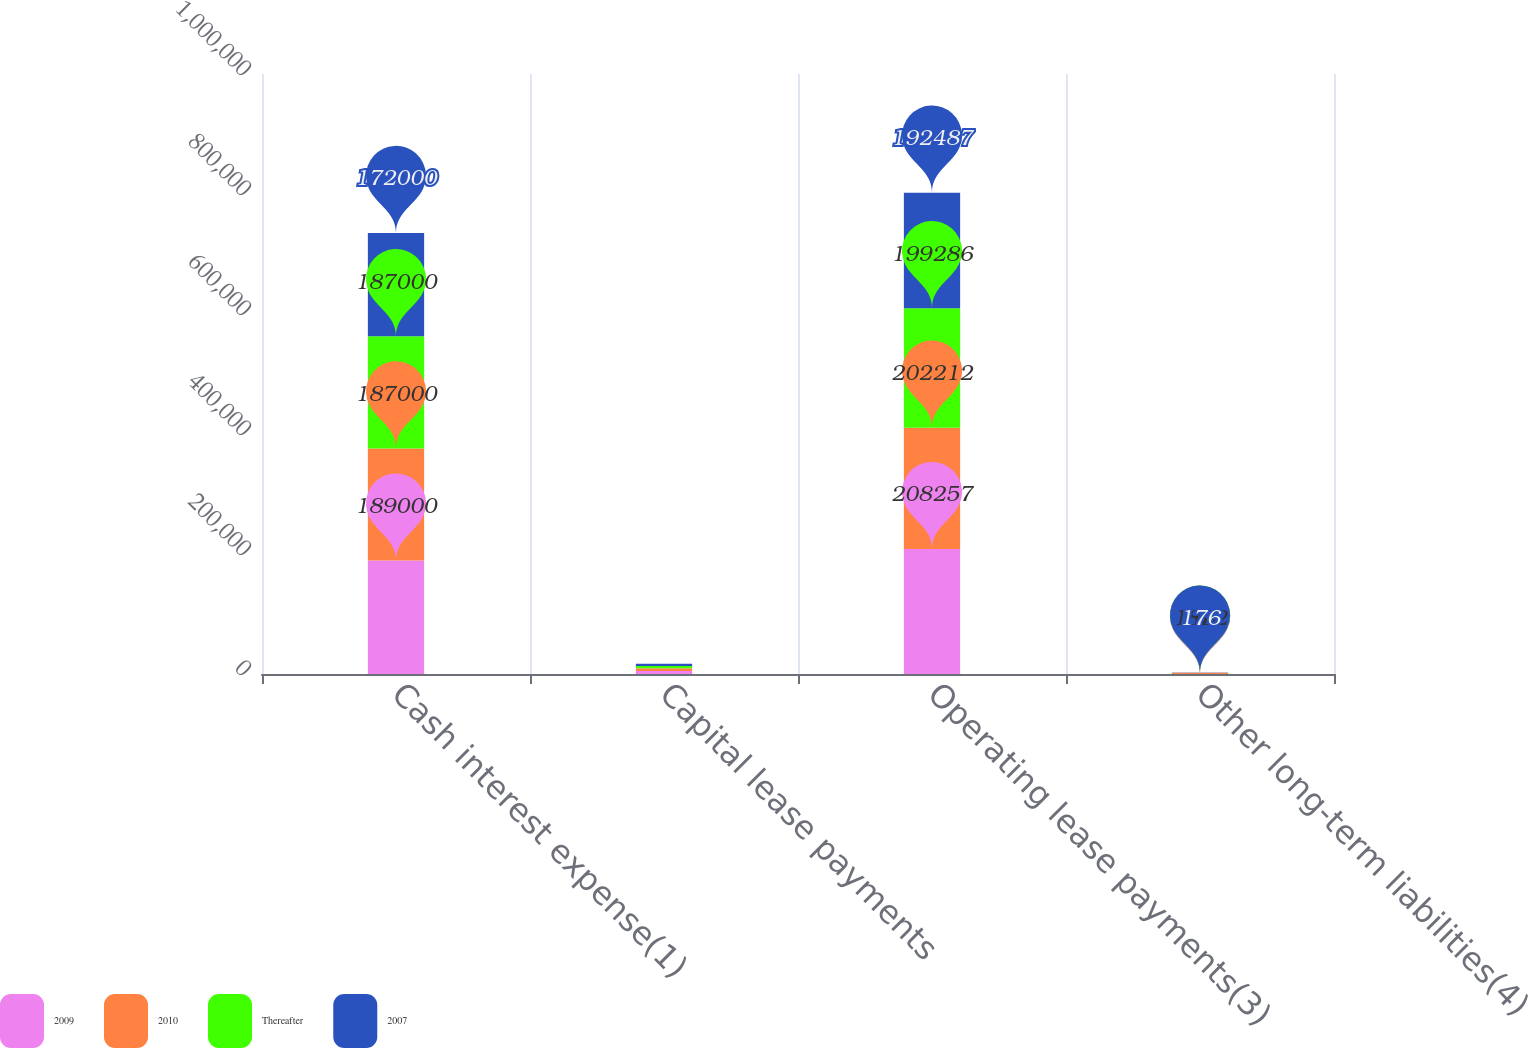Convert chart to OTSL. <chart><loc_0><loc_0><loc_500><loc_500><stacked_bar_chart><ecel><fcel>Cash interest expense(1)<fcel>Capital lease payments<fcel>Operating lease payments(3)<fcel>Other long-term liabilities(4)<nl><fcel>2009<fcel>189000<fcel>4965<fcel>208257<fcel>155<nl><fcel>2010<fcel>187000<fcel>4507<fcel>202212<fcel>1852<nl><fcel>Thereafter<fcel>187000<fcel>3880<fcel>199286<fcel>167<nl><fcel>2007<fcel>172000<fcel>3788<fcel>192487<fcel>176<nl></chart> 